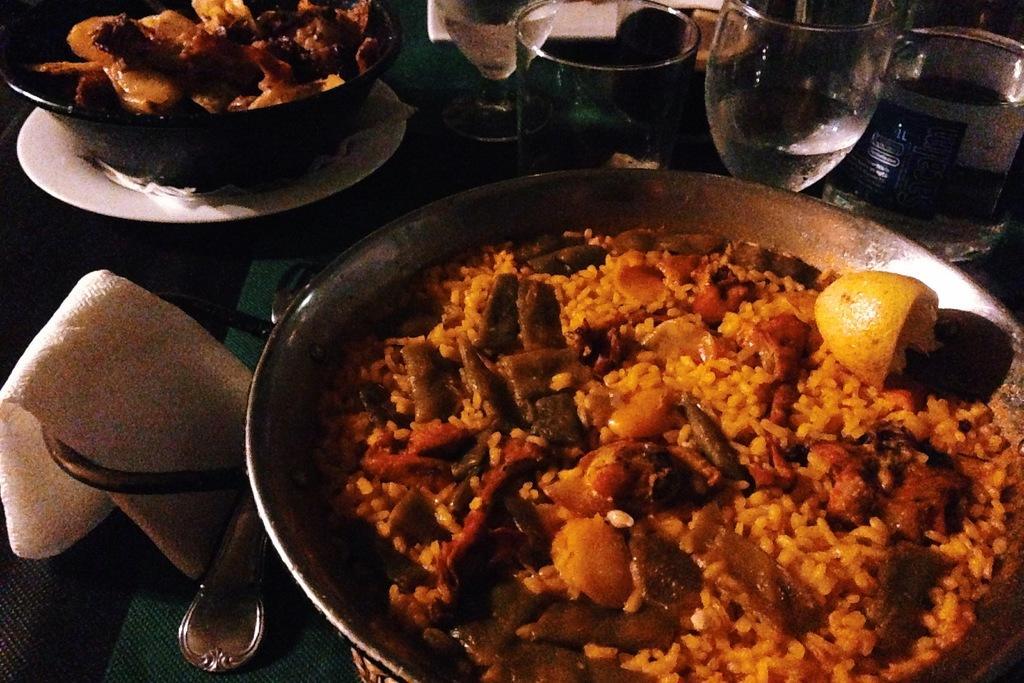How would you summarize this image in a sentence or two? In the picture we can see a dish with a curry in it, on it we can see a slice of a lemon and beside the dish we can see a plate with a small bowl with a curry in it and beside it we can see few glasses and water in it. 